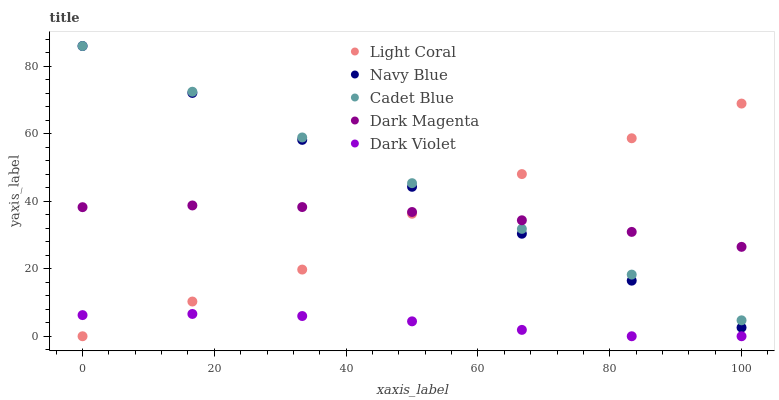Does Dark Violet have the minimum area under the curve?
Answer yes or no. Yes. Does Cadet Blue have the maximum area under the curve?
Answer yes or no. Yes. Does Navy Blue have the minimum area under the curve?
Answer yes or no. No. Does Navy Blue have the maximum area under the curve?
Answer yes or no. No. Is Cadet Blue the smoothest?
Answer yes or no. Yes. Is Light Coral the roughest?
Answer yes or no. Yes. Is Navy Blue the smoothest?
Answer yes or no. No. Is Navy Blue the roughest?
Answer yes or no. No. Does Light Coral have the lowest value?
Answer yes or no. Yes. Does Navy Blue have the lowest value?
Answer yes or no. No. Does Cadet Blue have the highest value?
Answer yes or no. Yes. Does Dark Magenta have the highest value?
Answer yes or no. No. Is Dark Violet less than Cadet Blue?
Answer yes or no. Yes. Is Cadet Blue greater than Dark Violet?
Answer yes or no. Yes. Does Light Coral intersect Cadet Blue?
Answer yes or no. Yes. Is Light Coral less than Cadet Blue?
Answer yes or no. No. Is Light Coral greater than Cadet Blue?
Answer yes or no. No. Does Dark Violet intersect Cadet Blue?
Answer yes or no. No. 